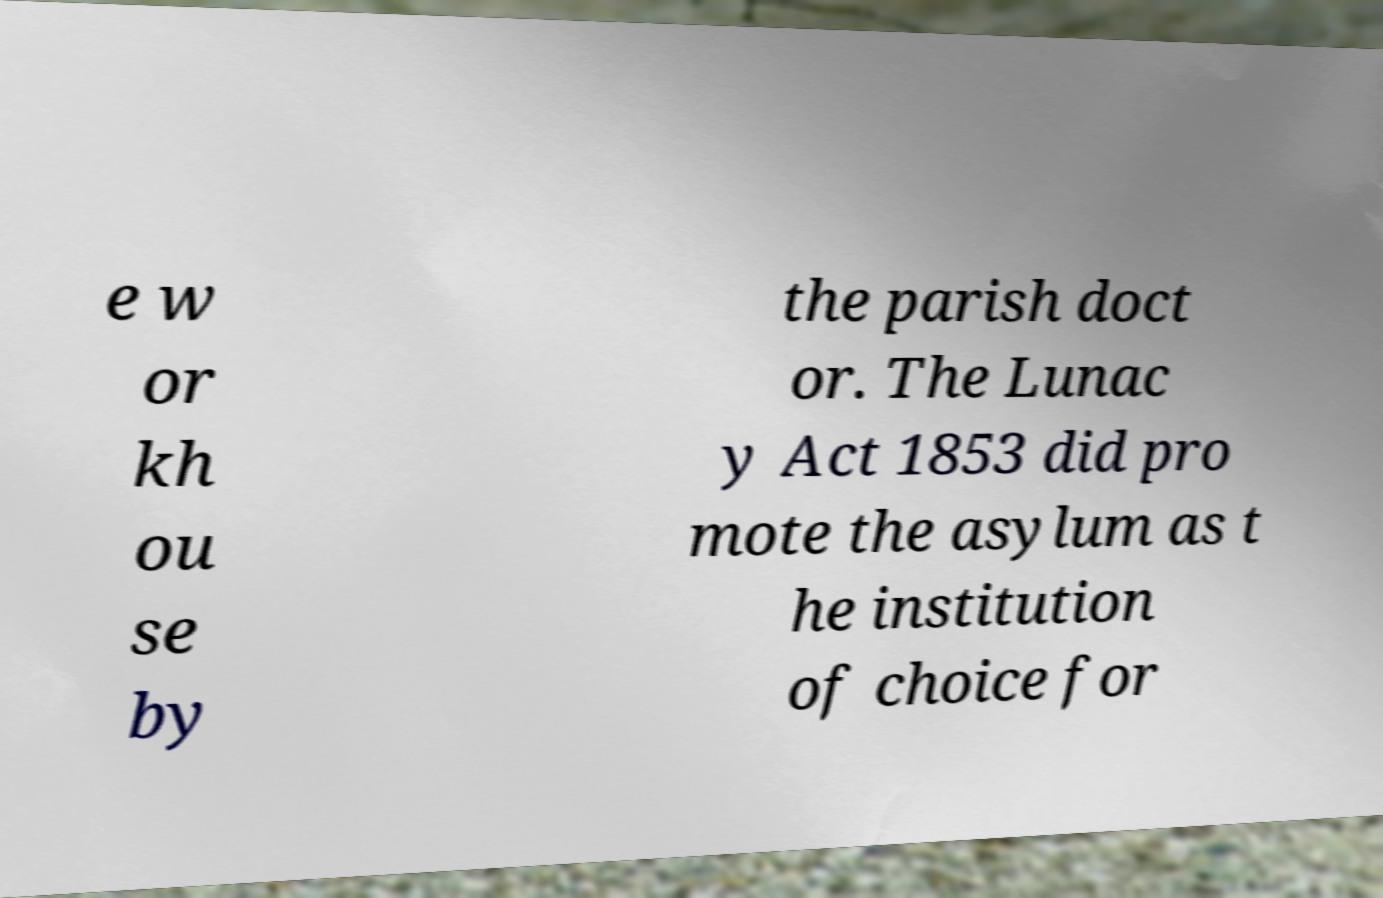Can you accurately transcribe the text from the provided image for me? e w or kh ou se by the parish doct or. The Lunac y Act 1853 did pro mote the asylum as t he institution of choice for 